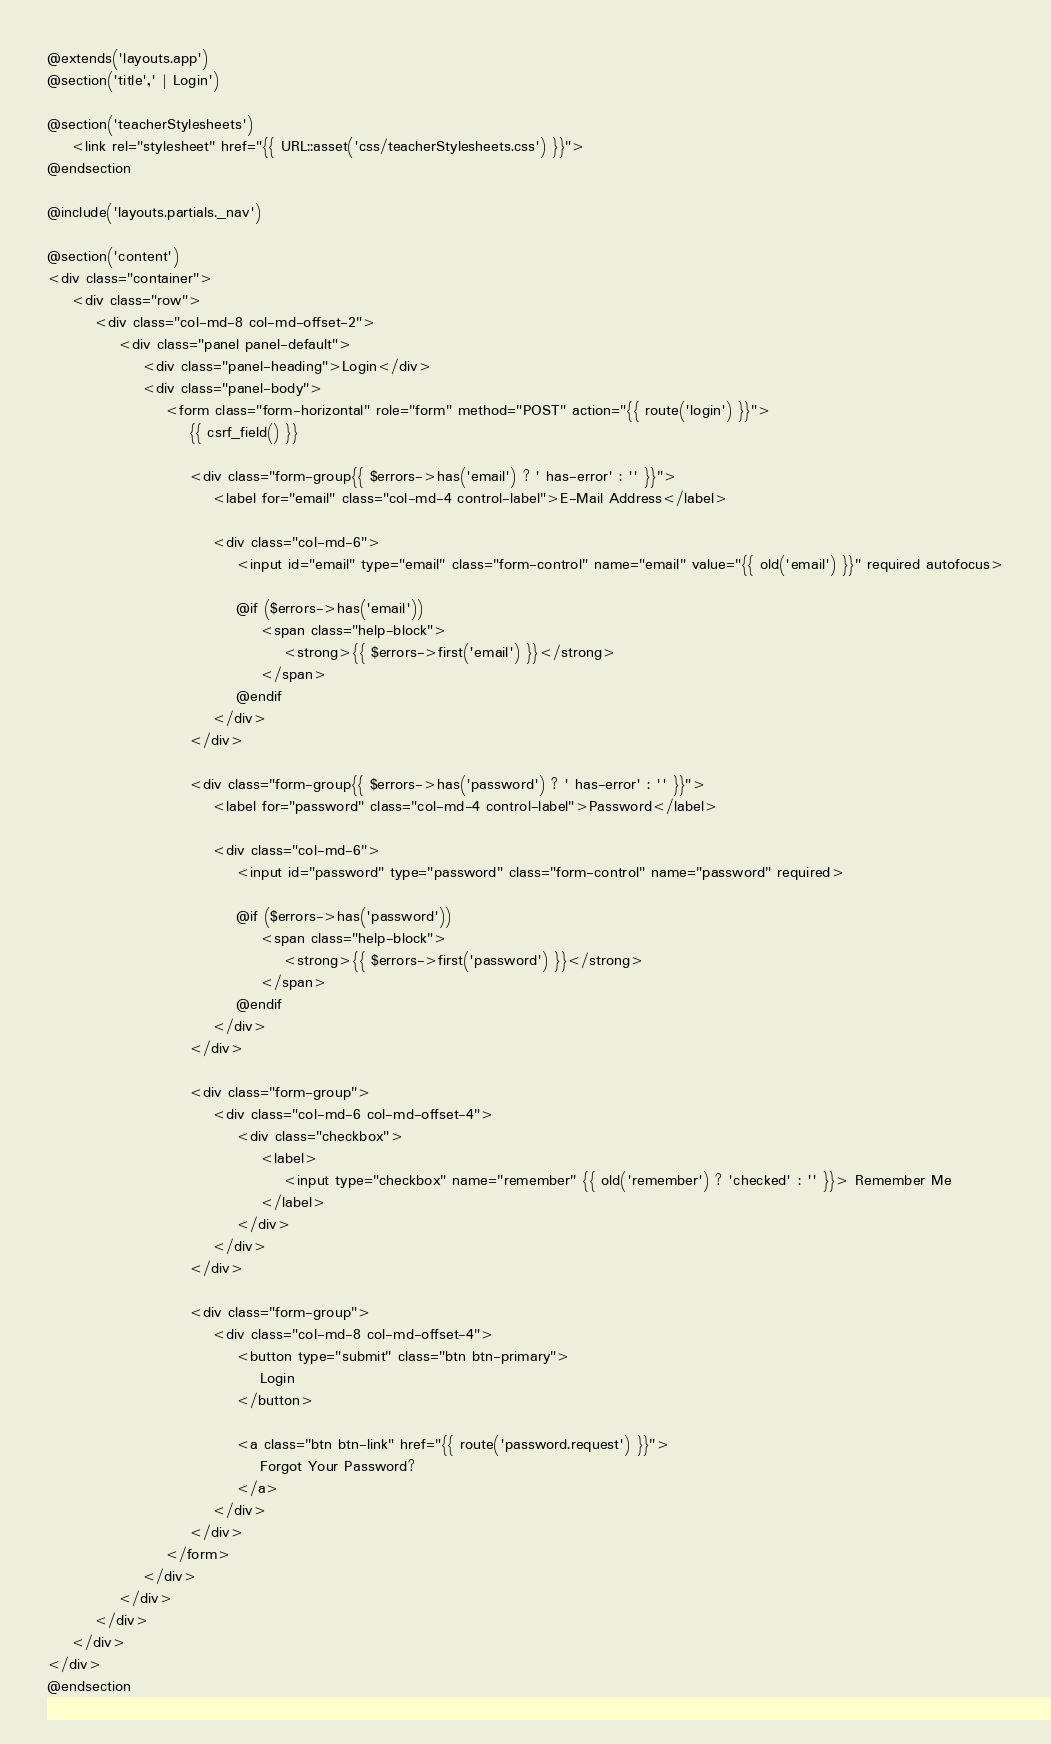<code> <loc_0><loc_0><loc_500><loc_500><_PHP_>@extends('layouts.app')
@section('title',' | Login')

@section('teacherStylesheets')
    <link rel="stylesheet" href="{{ URL::asset('css/teacherStylesheets.css') }}">
@endsection

@include('layouts.partials._nav')

@section('content')
<div class="container">
    <div class="row">
        <div class="col-md-8 col-md-offset-2">
            <div class="panel panel-default">
                <div class="panel-heading">Login</div>
                <div class="panel-body">
                    <form class="form-horizontal" role="form" method="POST" action="{{ route('login') }}">
                        {{ csrf_field() }}

                        <div class="form-group{{ $errors->has('email') ? ' has-error' : '' }}">
                            <label for="email" class="col-md-4 control-label">E-Mail Address</label>

                            <div class="col-md-6">
                                <input id="email" type="email" class="form-control" name="email" value="{{ old('email') }}" required autofocus>

                                @if ($errors->has('email'))
                                    <span class="help-block">
                                        <strong>{{ $errors->first('email') }}</strong>
                                    </span>
                                @endif
                            </div>
                        </div>

                        <div class="form-group{{ $errors->has('password') ? ' has-error' : '' }}">
                            <label for="password" class="col-md-4 control-label">Password</label>

                            <div class="col-md-6">
                                <input id="password" type="password" class="form-control" name="password" required>

                                @if ($errors->has('password'))
                                    <span class="help-block">
                                        <strong>{{ $errors->first('password') }}</strong>
                                    </span>
                                @endif
                            </div>
                        </div>

                        <div class="form-group">
                            <div class="col-md-6 col-md-offset-4">
                                <div class="checkbox">
                                    <label>
                                        <input type="checkbox" name="remember" {{ old('remember') ? 'checked' : '' }}> Remember Me
                                    </label>
                                </div>
                            </div>
                        </div>

                        <div class="form-group">
                            <div class="col-md-8 col-md-offset-4">
                                <button type="submit" class="btn btn-primary">
                                    Login
                                </button>

                                <a class="btn btn-link" href="{{ route('password.request') }}">
                                    Forgot Your Password?
                                </a>
                            </div>
                        </div>
                    </form>
                </div>
            </div>
        </div>
    </div>
</div>
@endsection
</code> 